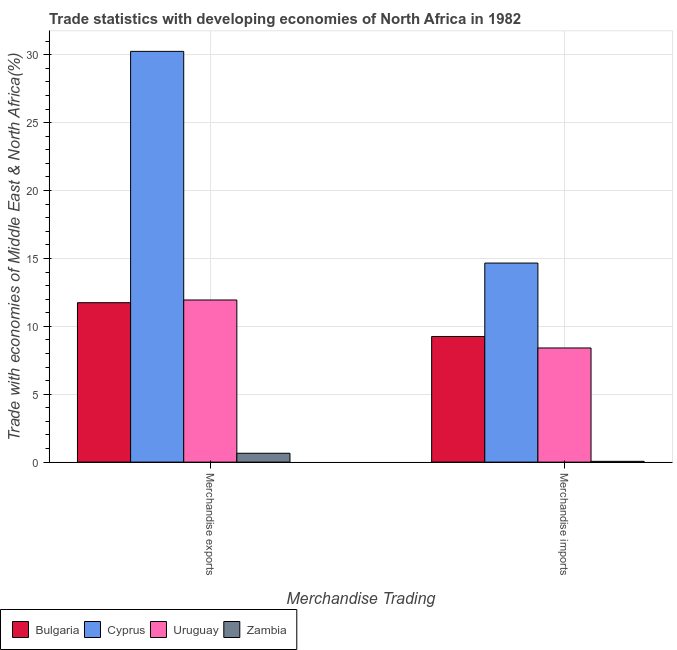How many groups of bars are there?
Offer a terse response. 2. Are the number of bars per tick equal to the number of legend labels?
Your answer should be very brief. Yes. How many bars are there on the 1st tick from the left?
Your response must be concise. 4. What is the merchandise imports in Bulgaria?
Give a very brief answer. 9.25. Across all countries, what is the maximum merchandise exports?
Give a very brief answer. 30.25. Across all countries, what is the minimum merchandise imports?
Provide a succinct answer. 0.06. In which country was the merchandise exports maximum?
Your answer should be very brief. Cyprus. In which country was the merchandise exports minimum?
Keep it short and to the point. Zambia. What is the total merchandise exports in the graph?
Provide a succinct answer. 54.58. What is the difference between the merchandise imports in Uruguay and that in Cyprus?
Your answer should be very brief. -6.25. What is the difference between the merchandise imports in Zambia and the merchandise exports in Cyprus?
Offer a terse response. -30.19. What is the average merchandise exports per country?
Offer a very short reply. 13.65. What is the difference between the merchandise imports and merchandise exports in Uruguay?
Provide a succinct answer. -3.53. In how many countries, is the merchandise exports greater than 24 %?
Your response must be concise. 1. What is the ratio of the merchandise exports in Uruguay to that in Zambia?
Provide a succinct answer. 18.29. What does the 4th bar from the left in Merchandise exports represents?
Offer a terse response. Zambia. Are the values on the major ticks of Y-axis written in scientific E-notation?
Provide a succinct answer. No. Does the graph contain grids?
Provide a succinct answer. Yes. Where does the legend appear in the graph?
Offer a terse response. Bottom left. How many legend labels are there?
Your response must be concise. 4. How are the legend labels stacked?
Provide a short and direct response. Horizontal. What is the title of the graph?
Ensure brevity in your answer.  Trade statistics with developing economies of North Africa in 1982. What is the label or title of the X-axis?
Provide a succinct answer. Merchandise Trading. What is the label or title of the Y-axis?
Keep it short and to the point. Trade with economies of Middle East & North Africa(%). What is the Trade with economies of Middle East & North Africa(%) in Bulgaria in Merchandise exports?
Make the answer very short. 11.74. What is the Trade with economies of Middle East & North Africa(%) of Cyprus in Merchandise exports?
Give a very brief answer. 30.25. What is the Trade with economies of Middle East & North Africa(%) in Uruguay in Merchandise exports?
Provide a short and direct response. 11.94. What is the Trade with economies of Middle East & North Africa(%) in Zambia in Merchandise exports?
Provide a short and direct response. 0.65. What is the Trade with economies of Middle East & North Africa(%) in Bulgaria in Merchandise imports?
Ensure brevity in your answer.  9.25. What is the Trade with economies of Middle East & North Africa(%) in Cyprus in Merchandise imports?
Make the answer very short. 14.66. What is the Trade with economies of Middle East & North Africa(%) of Uruguay in Merchandise imports?
Provide a short and direct response. 8.41. What is the Trade with economies of Middle East & North Africa(%) in Zambia in Merchandise imports?
Your response must be concise. 0.06. Across all Merchandise Trading, what is the maximum Trade with economies of Middle East & North Africa(%) in Bulgaria?
Your response must be concise. 11.74. Across all Merchandise Trading, what is the maximum Trade with economies of Middle East & North Africa(%) in Cyprus?
Make the answer very short. 30.25. Across all Merchandise Trading, what is the maximum Trade with economies of Middle East & North Africa(%) in Uruguay?
Offer a terse response. 11.94. Across all Merchandise Trading, what is the maximum Trade with economies of Middle East & North Africa(%) of Zambia?
Make the answer very short. 0.65. Across all Merchandise Trading, what is the minimum Trade with economies of Middle East & North Africa(%) in Bulgaria?
Provide a short and direct response. 9.25. Across all Merchandise Trading, what is the minimum Trade with economies of Middle East & North Africa(%) in Cyprus?
Provide a short and direct response. 14.66. Across all Merchandise Trading, what is the minimum Trade with economies of Middle East & North Africa(%) in Uruguay?
Make the answer very short. 8.41. Across all Merchandise Trading, what is the minimum Trade with economies of Middle East & North Africa(%) in Zambia?
Ensure brevity in your answer.  0.06. What is the total Trade with economies of Middle East & North Africa(%) in Bulgaria in the graph?
Your answer should be compact. 20.99. What is the total Trade with economies of Middle East & North Africa(%) in Cyprus in the graph?
Offer a terse response. 44.91. What is the total Trade with economies of Middle East & North Africa(%) in Uruguay in the graph?
Offer a terse response. 20.34. What is the total Trade with economies of Middle East & North Africa(%) in Zambia in the graph?
Your answer should be compact. 0.71. What is the difference between the Trade with economies of Middle East & North Africa(%) of Bulgaria in Merchandise exports and that in Merchandise imports?
Offer a terse response. 2.49. What is the difference between the Trade with economies of Middle East & North Africa(%) in Cyprus in Merchandise exports and that in Merchandise imports?
Your answer should be very brief. 15.59. What is the difference between the Trade with economies of Middle East & North Africa(%) in Uruguay in Merchandise exports and that in Merchandise imports?
Your answer should be compact. 3.53. What is the difference between the Trade with economies of Middle East & North Africa(%) of Zambia in Merchandise exports and that in Merchandise imports?
Your answer should be very brief. 0.6. What is the difference between the Trade with economies of Middle East & North Africa(%) of Bulgaria in Merchandise exports and the Trade with economies of Middle East & North Africa(%) of Cyprus in Merchandise imports?
Your response must be concise. -2.92. What is the difference between the Trade with economies of Middle East & North Africa(%) of Bulgaria in Merchandise exports and the Trade with economies of Middle East & North Africa(%) of Uruguay in Merchandise imports?
Keep it short and to the point. 3.34. What is the difference between the Trade with economies of Middle East & North Africa(%) in Bulgaria in Merchandise exports and the Trade with economies of Middle East & North Africa(%) in Zambia in Merchandise imports?
Your answer should be very brief. 11.68. What is the difference between the Trade with economies of Middle East & North Africa(%) of Cyprus in Merchandise exports and the Trade with economies of Middle East & North Africa(%) of Uruguay in Merchandise imports?
Provide a succinct answer. 21.84. What is the difference between the Trade with economies of Middle East & North Africa(%) in Cyprus in Merchandise exports and the Trade with economies of Middle East & North Africa(%) in Zambia in Merchandise imports?
Make the answer very short. 30.19. What is the difference between the Trade with economies of Middle East & North Africa(%) of Uruguay in Merchandise exports and the Trade with economies of Middle East & North Africa(%) of Zambia in Merchandise imports?
Offer a very short reply. 11.88. What is the average Trade with economies of Middle East & North Africa(%) of Bulgaria per Merchandise Trading?
Give a very brief answer. 10.5. What is the average Trade with economies of Middle East & North Africa(%) of Cyprus per Merchandise Trading?
Your response must be concise. 22.45. What is the average Trade with economies of Middle East & North Africa(%) of Uruguay per Merchandise Trading?
Make the answer very short. 10.17. What is the average Trade with economies of Middle East & North Africa(%) of Zambia per Merchandise Trading?
Keep it short and to the point. 0.36. What is the difference between the Trade with economies of Middle East & North Africa(%) in Bulgaria and Trade with economies of Middle East & North Africa(%) in Cyprus in Merchandise exports?
Your answer should be compact. -18.51. What is the difference between the Trade with economies of Middle East & North Africa(%) of Bulgaria and Trade with economies of Middle East & North Africa(%) of Uruguay in Merchandise exports?
Your answer should be very brief. -0.2. What is the difference between the Trade with economies of Middle East & North Africa(%) in Bulgaria and Trade with economies of Middle East & North Africa(%) in Zambia in Merchandise exports?
Offer a very short reply. 11.09. What is the difference between the Trade with economies of Middle East & North Africa(%) of Cyprus and Trade with economies of Middle East & North Africa(%) of Uruguay in Merchandise exports?
Your response must be concise. 18.31. What is the difference between the Trade with economies of Middle East & North Africa(%) of Cyprus and Trade with economies of Middle East & North Africa(%) of Zambia in Merchandise exports?
Provide a succinct answer. 29.59. What is the difference between the Trade with economies of Middle East & North Africa(%) in Uruguay and Trade with economies of Middle East & North Africa(%) in Zambia in Merchandise exports?
Provide a short and direct response. 11.29. What is the difference between the Trade with economies of Middle East & North Africa(%) in Bulgaria and Trade with economies of Middle East & North Africa(%) in Cyprus in Merchandise imports?
Keep it short and to the point. -5.41. What is the difference between the Trade with economies of Middle East & North Africa(%) in Bulgaria and Trade with economies of Middle East & North Africa(%) in Uruguay in Merchandise imports?
Give a very brief answer. 0.85. What is the difference between the Trade with economies of Middle East & North Africa(%) in Bulgaria and Trade with economies of Middle East & North Africa(%) in Zambia in Merchandise imports?
Your answer should be very brief. 9.19. What is the difference between the Trade with economies of Middle East & North Africa(%) in Cyprus and Trade with economies of Middle East & North Africa(%) in Uruguay in Merchandise imports?
Offer a very short reply. 6.25. What is the difference between the Trade with economies of Middle East & North Africa(%) in Cyprus and Trade with economies of Middle East & North Africa(%) in Zambia in Merchandise imports?
Give a very brief answer. 14.6. What is the difference between the Trade with economies of Middle East & North Africa(%) in Uruguay and Trade with economies of Middle East & North Africa(%) in Zambia in Merchandise imports?
Your answer should be very brief. 8.35. What is the ratio of the Trade with economies of Middle East & North Africa(%) in Bulgaria in Merchandise exports to that in Merchandise imports?
Make the answer very short. 1.27. What is the ratio of the Trade with economies of Middle East & North Africa(%) in Cyprus in Merchandise exports to that in Merchandise imports?
Provide a succinct answer. 2.06. What is the ratio of the Trade with economies of Middle East & North Africa(%) of Uruguay in Merchandise exports to that in Merchandise imports?
Your answer should be compact. 1.42. What is the ratio of the Trade with economies of Middle East & North Africa(%) of Zambia in Merchandise exports to that in Merchandise imports?
Offer a very short reply. 11.3. What is the difference between the highest and the second highest Trade with economies of Middle East & North Africa(%) of Bulgaria?
Your answer should be very brief. 2.49. What is the difference between the highest and the second highest Trade with economies of Middle East & North Africa(%) in Cyprus?
Give a very brief answer. 15.59. What is the difference between the highest and the second highest Trade with economies of Middle East & North Africa(%) in Uruguay?
Give a very brief answer. 3.53. What is the difference between the highest and the second highest Trade with economies of Middle East & North Africa(%) in Zambia?
Make the answer very short. 0.6. What is the difference between the highest and the lowest Trade with economies of Middle East & North Africa(%) of Bulgaria?
Provide a short and direct response. 2.49. What is the difference between the highest and the lowest Trade with economies of Middle East & North Africa(%) of Cyprus?
Make the answer very short. 15.59. What is the difference between the highest and the lowest Trade with economies of Middle East & North Africa(%) in Uruguay?
Your response must be concise. 3.53. What is the difference between the highest and the lowest Trade with economies of Middle East & North Africa(%) of Zambia?
Your response must be concise. 0.6. 